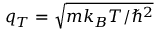Convert formula to latex. <formula><loc_0><loc_0><loc_500><loc_500>q _ { T } = \sqrt { m k _ { B } T / \hbar { ^ } { 2 } }</formula> 